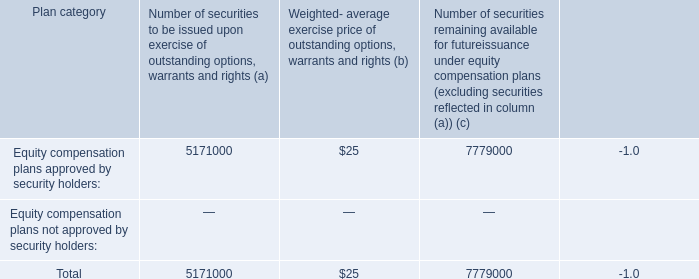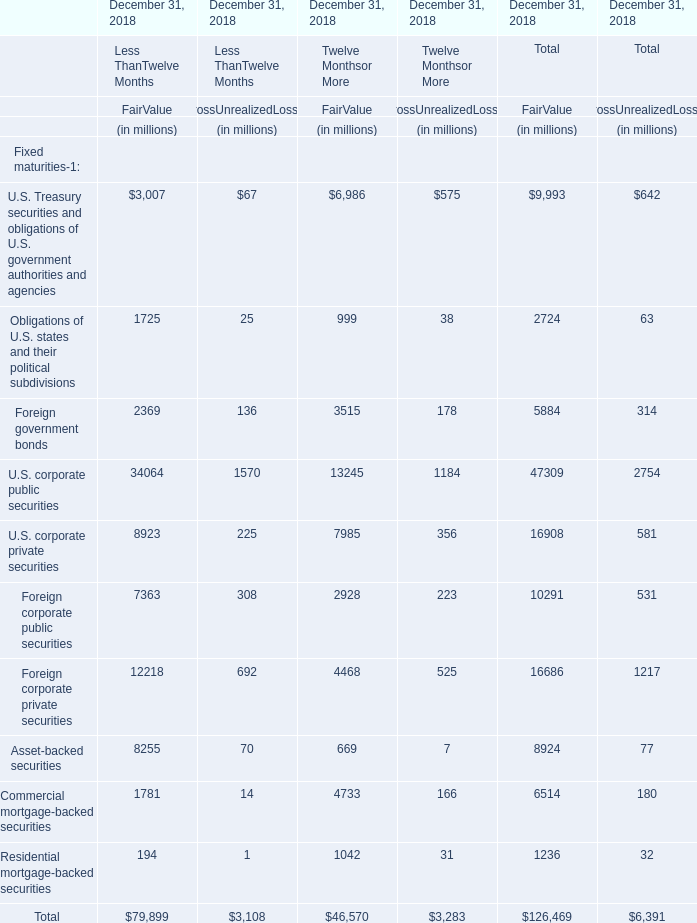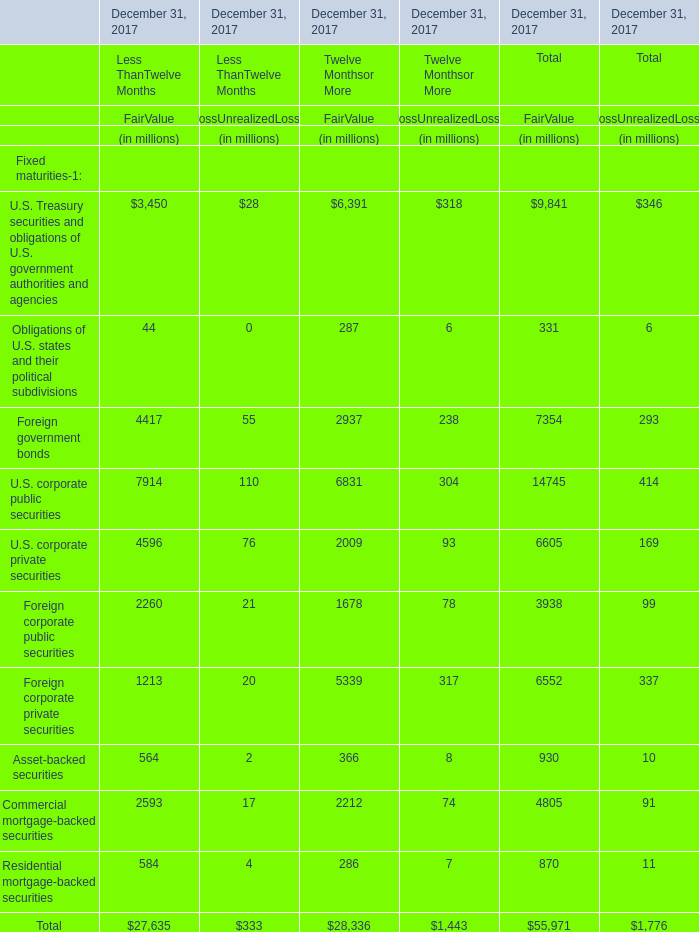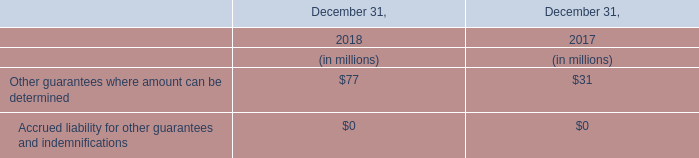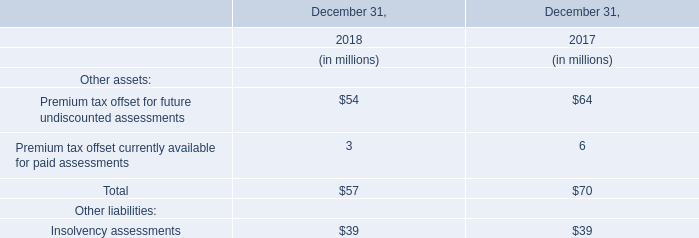What was the average value of Foreign government bonds, U.S. corporate public securities,U.S. corporate private securities for FairValue of Twelve Monthsor More ? (in million) 
Computations: (((2937 + 6831) + 2009) / 3)
Answer: 3925.66667. 